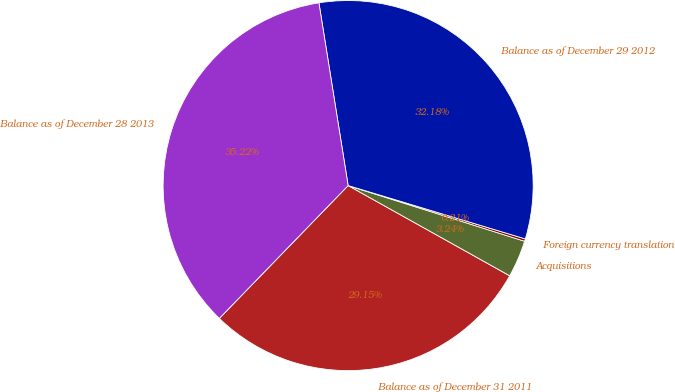Convert chart. <chart><loc_0><loc_0><loc_500><loc_500><pie_chart><fcel>Balance as of December 31 2011<fcel>Acquisitions<fcel>Foreign currency translation<fcel>Balance as of December 29 2012<fcel>Balance as of December 28 2013<nl><fcel>29.15%<fcel>3.24%<fcel>0.21%<fcel>32.18%<fcel>35.22%<nl></chart> 